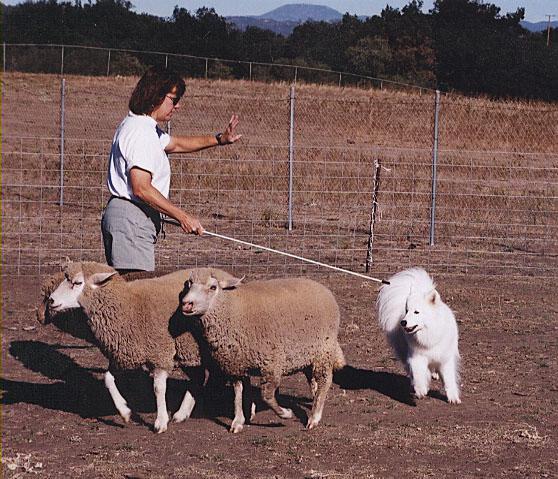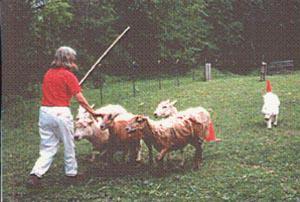The first image is the image on the left, the second image is the image on the right. Considering the images on both sides, is "A girl wearing a blue sweatshirt is with a white dog and some sheep." valid? Answer yes or no. No. The first image is the image on the left, the second image is the image on the right. Given the left and right images, does the statement "There is a dog herding sheep and one woman in each image" hold true? Answer yes or no. Yes. 